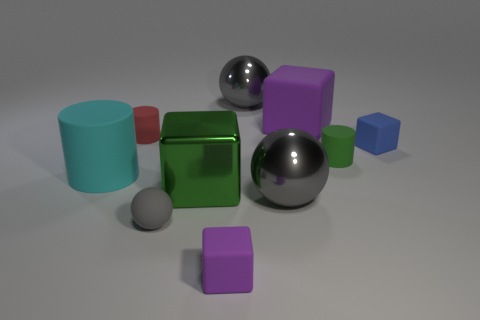There is a rubber cylinder that is on the right side of the red matte cylinder; is there a big gray metallic sphere in front of it?
Offer a terse response. Yes. What number of other objects are there of the same shape as the large purple rubber object?
Ensure brevity in your answer.  3. Is the shape of the tiny blue matte thing the same as the big green metallic thing?
Offer a terse response. Yes. What color is the tiny matte thing that is behind the small gray ball and on the left side of the small purple thing?
Ensure brevity in your answer.  Red. What number of big objects are purple rubber blocks or green metal cubes?
Provide a succinct answer. 2. Are there any other things of the same color as the large matte cube?
Your answer should be very brief. Yes. What material is the large cube that is to the left of the purple matte cube that is in front of the large rubber object on the right side of the cyan matte thing made of?
Offer a very short reply. Metal. What number of matte objects are either large yellow balls or big gray spheres?
Your response must be concise. 0. How many blue objects are either big cylinders or metallic balls?
Offer a terse response. 0. There is a small block that is behind the small gray rubber thing; is its color the same as the tiny rubber ball?
Offer a terse response. No. 